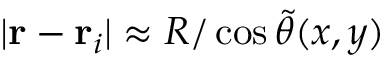<formula> <loc_0><loc_0><loc_500><loc_500>| r - r _ { i } | \approx R / \cos \tilde { \theta } ( x , y )</formula> 